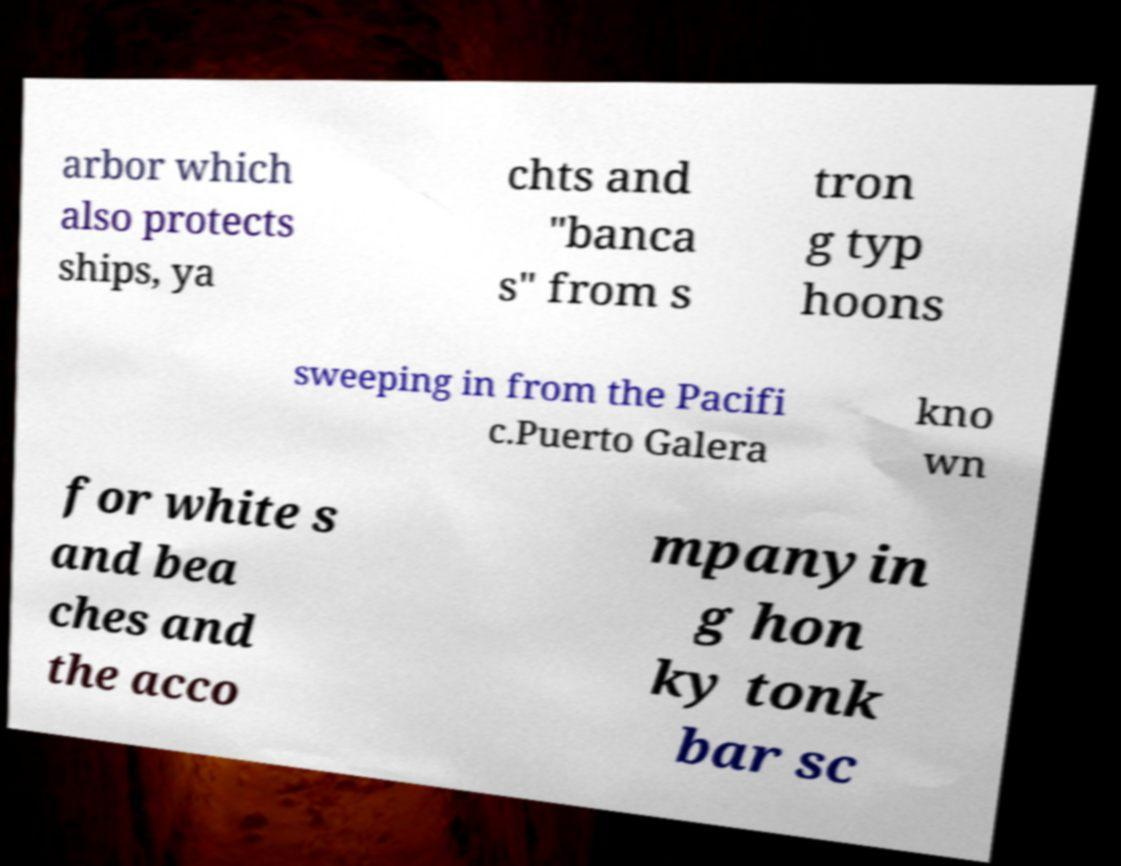There's text embedded in this image that I need extracted. Can you transcribe it verbatim? arbor which also protects ships, ya chts and "banca s" from s tron g typ hoons sweeping in from the Pacifi c.Puerto Galera kno wn for white s and bea ches and the acco mpanyin g hon ky tonk bar sc 